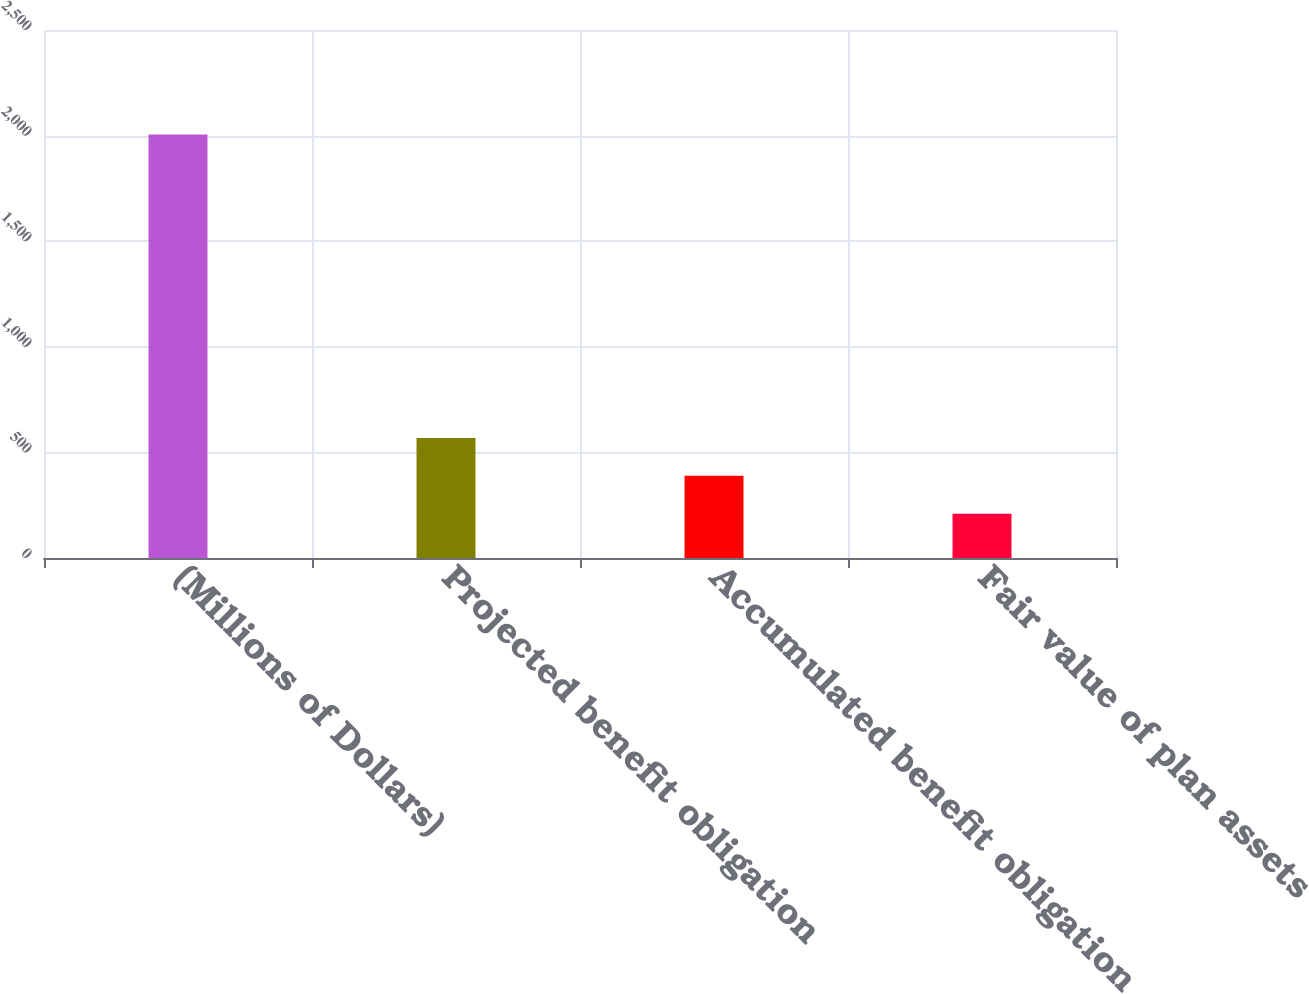Convert chart to OTSL. <chart><loc_0><loc_0><loc_500><loc_500><bar_chart><fcel>(Millions of Dollars)<fcel>Projected benefit obligation<fcel>Accumulated benefit obligation<fcel>Fair value of plan assets<nl><fcel>2005<fcel>568.76<fcel>389.23<fcel>209.7<nl></chart> 